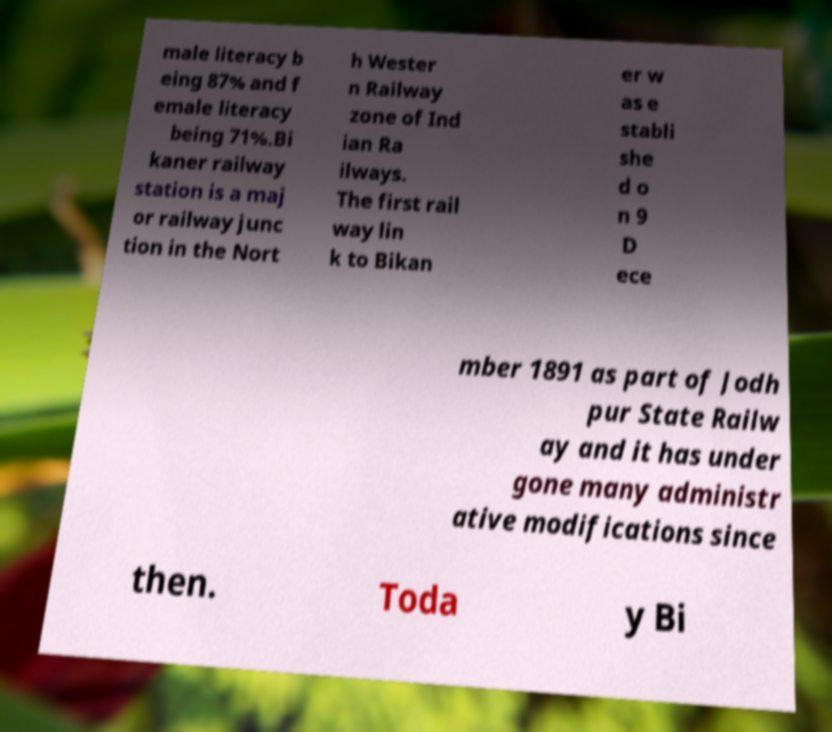Please read and relay the text visible in this image. What does it say? male literacy b eing 87% and f emale literacy being 71%.Bi kaner railway station is a maj or railway junc tion in the Nort h Wester n Railway zone of Ind ian Ra ilways. The first rail way lin k to Bikan er w as e stabli she d o n 9 D ece mber 1891 as part of Jodh pur State Railw ay and it has under gone many administr ative modifications since then. Toda y Bi 